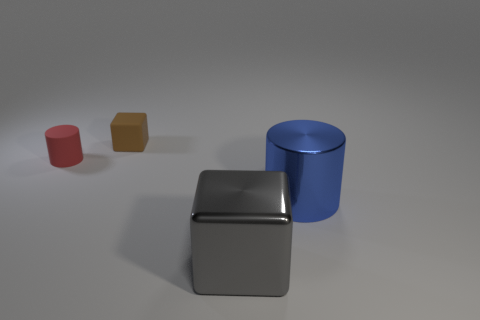Are there any large gray metal things of the same shape as the big blue metal thing?
Your response must be concise. No. What number of objects are either small red cylinders or things in front of the red rubber cylinder?
Your answer should be compact. 3. How many other objects are there of the same material as the brown thing?
Provide a short and direct response. 1. What number of things are either tiny objects or matte cylinders?
Your answer should be compact. 2. Are there more rubber objects on the right side of the small red matte thing than small red matte cylinders that are in front of the gray thing?
Give a very brief answer. Yes. There is a object left of the cube behind the object that is left of the brown rubber block; what size is it?
Ensure brevity in your answer.  Small. There is another tiny rubber thing that is the same shape as the blue thing; what is its color?
Make the answer very short. Red. Are there more things that are in front of the small cylinder than small purple metallic things?
Ensure brevity in your answer.  Yes. There is a blue shiny object; is its shape the same as the object to the left of the small brown matte thing?
Offer a terse response. Yes. What size is the other thing that is the same shape as the tiny brown matte thing?
Offer a terse response. Large. 